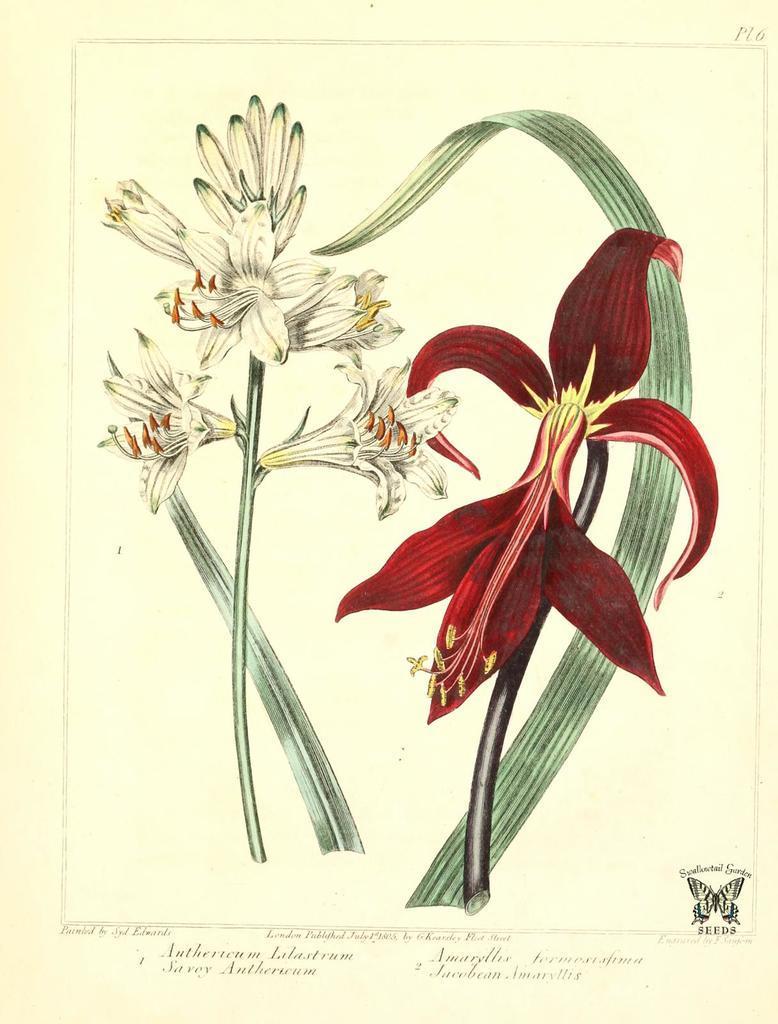Describe this image in one or two sentences. In this image I can see painting of flowers. I can see colour of these flowers are red and white. Here I can see something is written. 